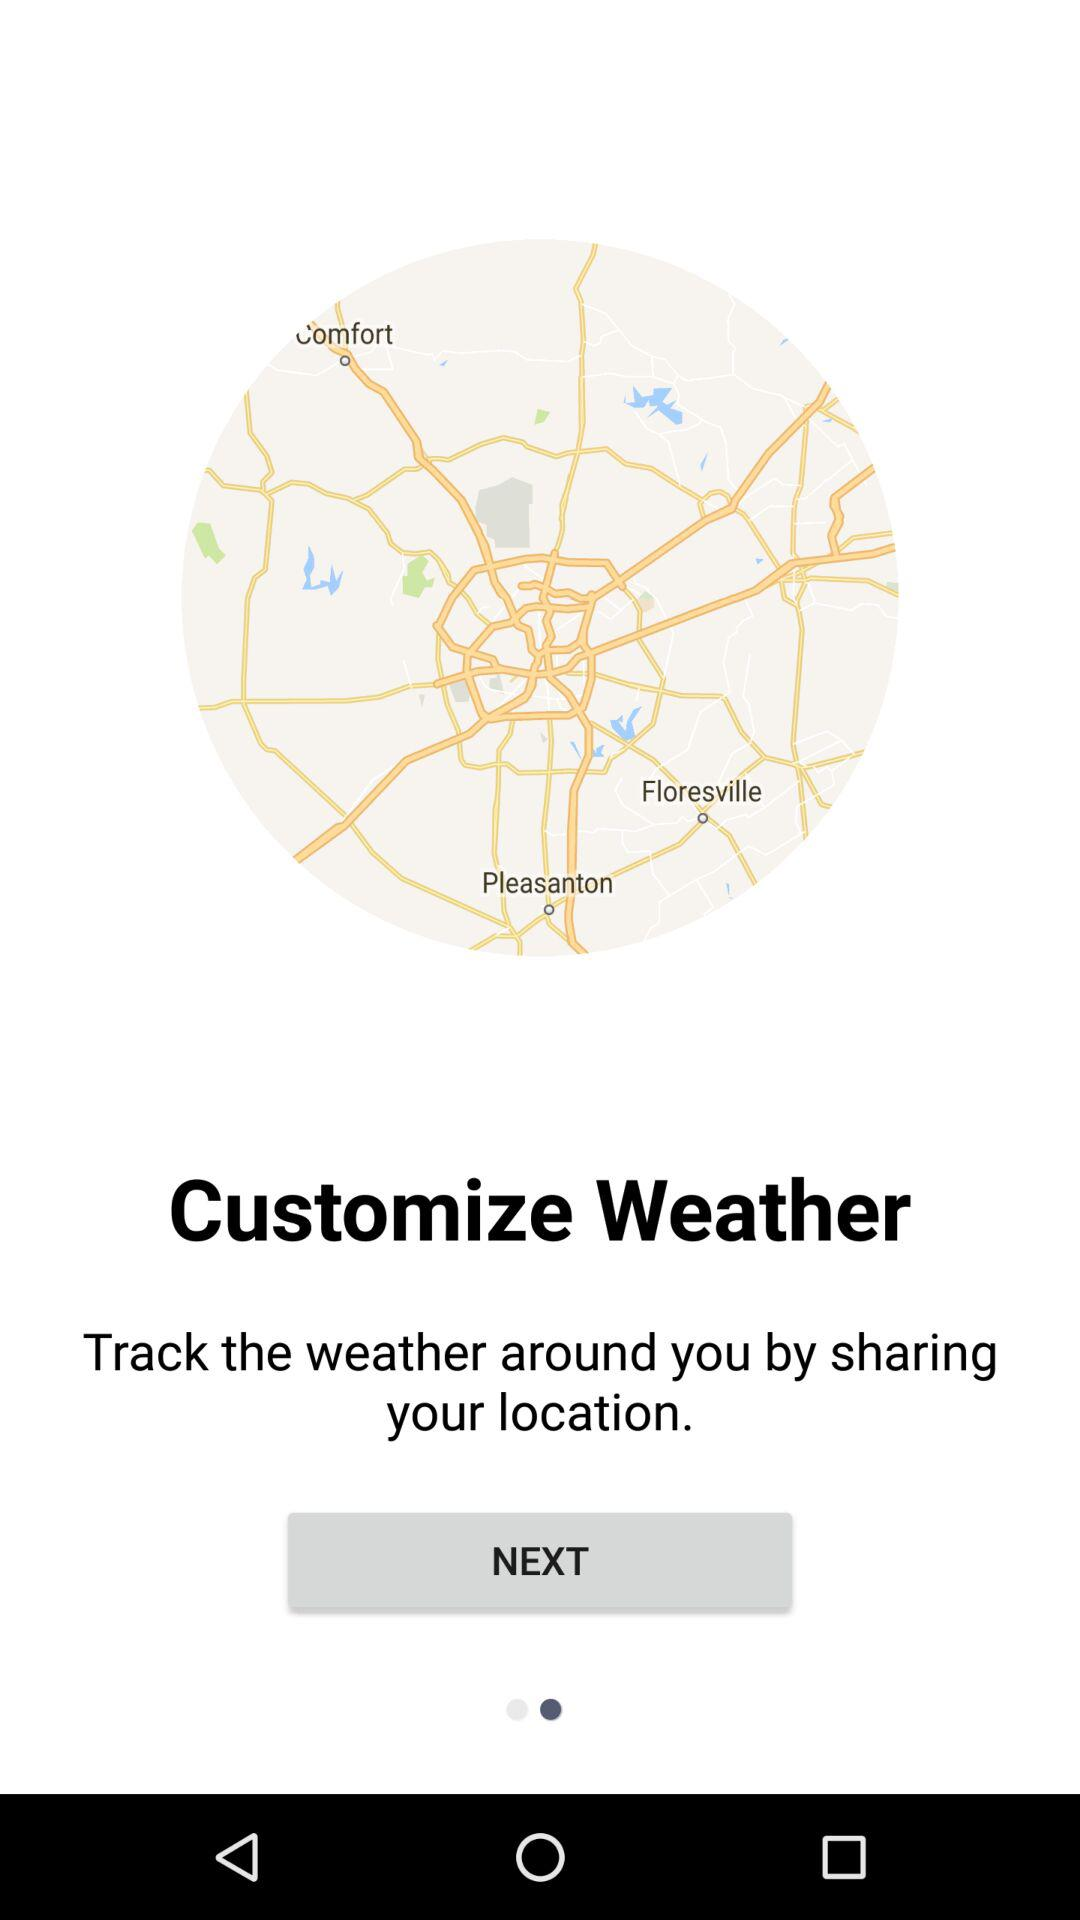How to track the weather? Track the weather by sharing your location. 